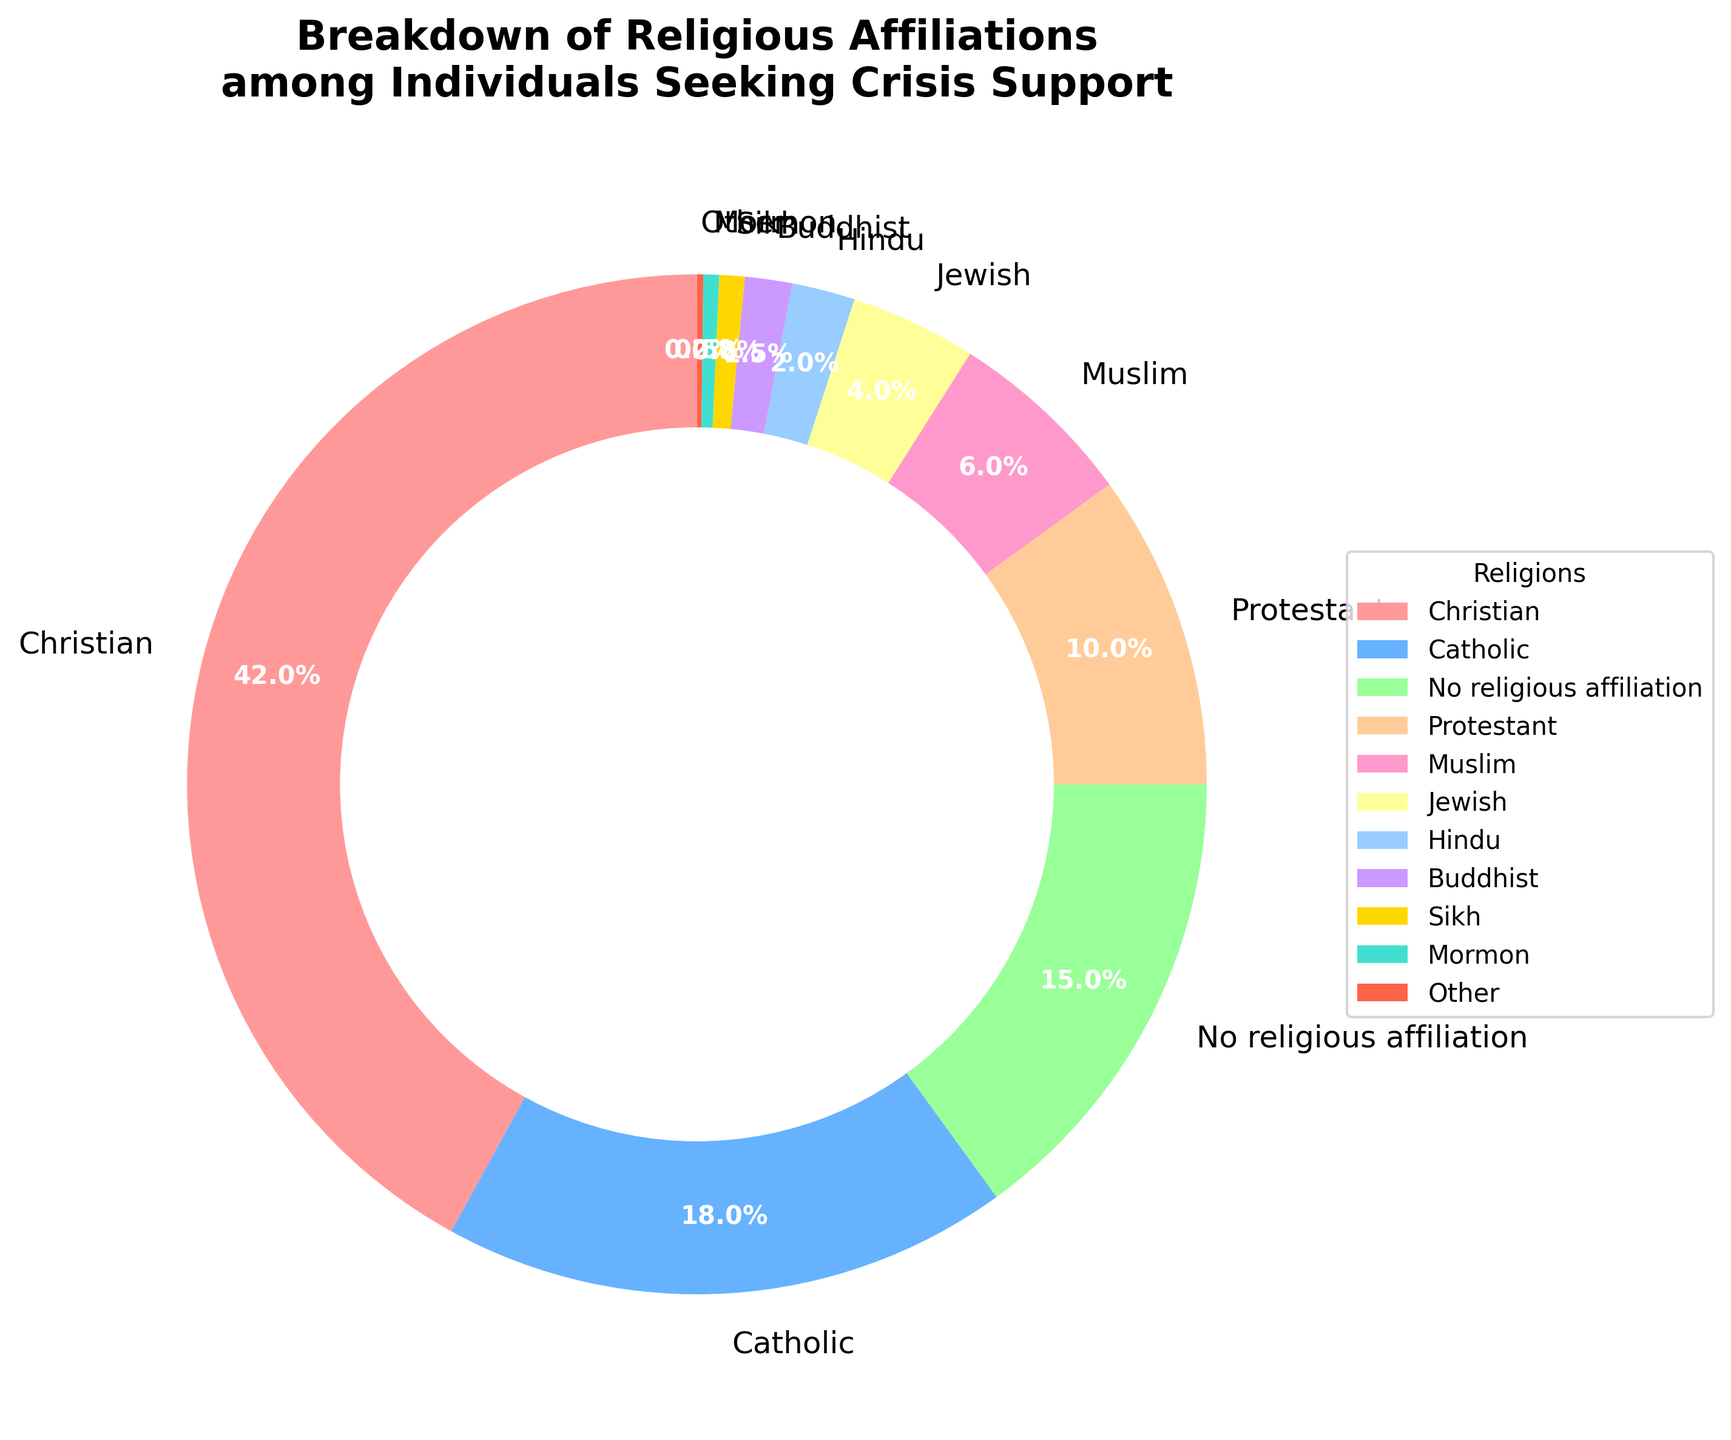What is the largest religious affiliation among individuals seeking crisis support? The figure shows the breakdown of religious affiliations. By looking at the pie chart, it's clear that the largest segment is for Christians.
Answer: Christian Which religious affiliation has the smallest percentage? The figure shows the various religious affiliations with their respective percentages. The smallest segment is labeled "Other" with 0.2%.
Answer: Other How does the percentage of individuals with 'No religious affiliation' compare to those who are 'Muslim'? By observing the pie chart, we see that 'No religious affiliation' is 15% while 'Muslim' is 6%. Therefore, 'No religious affiliation' is greater.
Answer: 'No religious affiliation' is greater What is the sum of the percentages for 'Jewish', 'Hindu', and 'Buddhist'? Sum the percentages for these three affiliations: Jewish (4%) + Hindu (2%) + Buddhist (1.5%), which gives 4 + 2 + 1.5 = 7.5%.
Answer: 7.5% How much more percentage do 'Catholics' make up compared to 'Protestants'? Subtract the percentage of Protestants (10%) from the percentage of Catholics (18%). The difference is 18 - 10 = 8%.
Answer: 8% Which religious affiliation is represented by a red segment in the pie chart? According to the description, the color scheme uses red as one of the custom colors. The largest and often most prominent color (red) in many charts is used for the largest affiliation, Christian.
Answer: Christian What is the total percentage of individuals who identify as either 'Sikh' or 'Mormon'? Add the percentages for 'Sikh' (0.8%) and 'Mormon' (0.5%), which equals 0.8 + 0.5 = 1.3%.
Answer: 1.3% What is the average percentage of 'Catholic', 'Hindu', and 'Muslim' groups? First, find the sum of the percentages for these three groups: Catholic (18%) + Hindu (2%) + Muslim (6%). Sum is 18 + 2 + 6 = 26. Then, divide by 3 for the average: 26 / 3 ≈ 8.67%.
Answer: 8.67% How do the total percentages of 'Christian' and 'No religious affiliation' compare? Add the percentage values for Christian (42%) and No religious affiliation (15%). 42 is greater than 15, making the total percentage much higher for Christian.
Answer: Christian is higher By how much does the total percentage of 'Christian', 'Catholic', and 'Protestant' exceed the combined percentage of 'No religious affiliation' and 'Muslim'? Sum the percentages for Christian (42%), Catholic (18%), and Protestant (10%) first: 42 + 18 + 10 = 70%. Then sum No religious affiliation (15%) and Muslim (6%): 15 + 6 = 21%. The difference is 70% - 21% = 49%.
Answer: 49% 